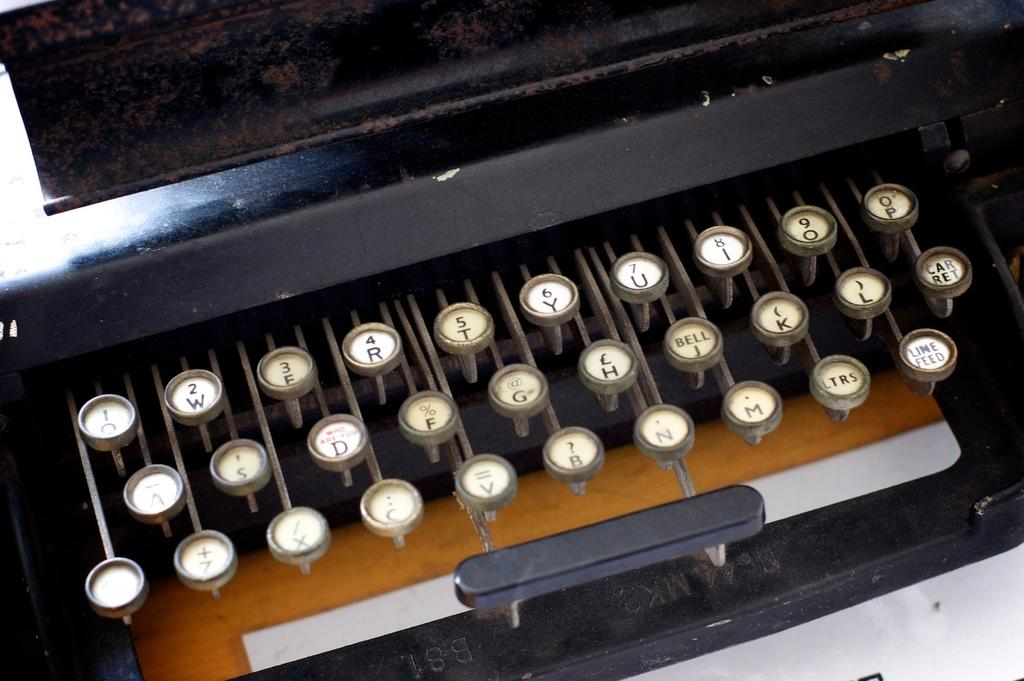Provide a one-sentence caption for the provided image. close up of old manual typewriter with keys showing q,w,e,r,t,y,u,i,o,p and somewhat less visible 2 rows below. 